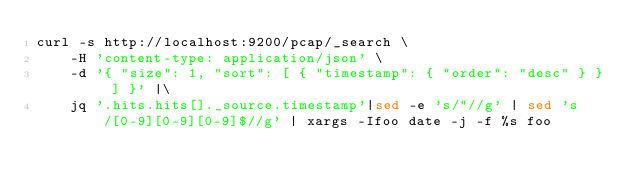<code> <loc_0><loc_0><loc_500><loc_500><_Bash_>curl -s http://localhost:9200/pcap/_search \
    -H 'content-type: application/json' \
    -d '{ "size": 1, "sort": [ { "timestamp": { "order": "desc" } } ] }' |\
    jq '.hits.hits[]._source.timestamp'|sed -e 's/"//g' | sed 's/[0-9][0-9][0-9]$//g' | xargs -Ifoo date -j -f %s foo
</code> 